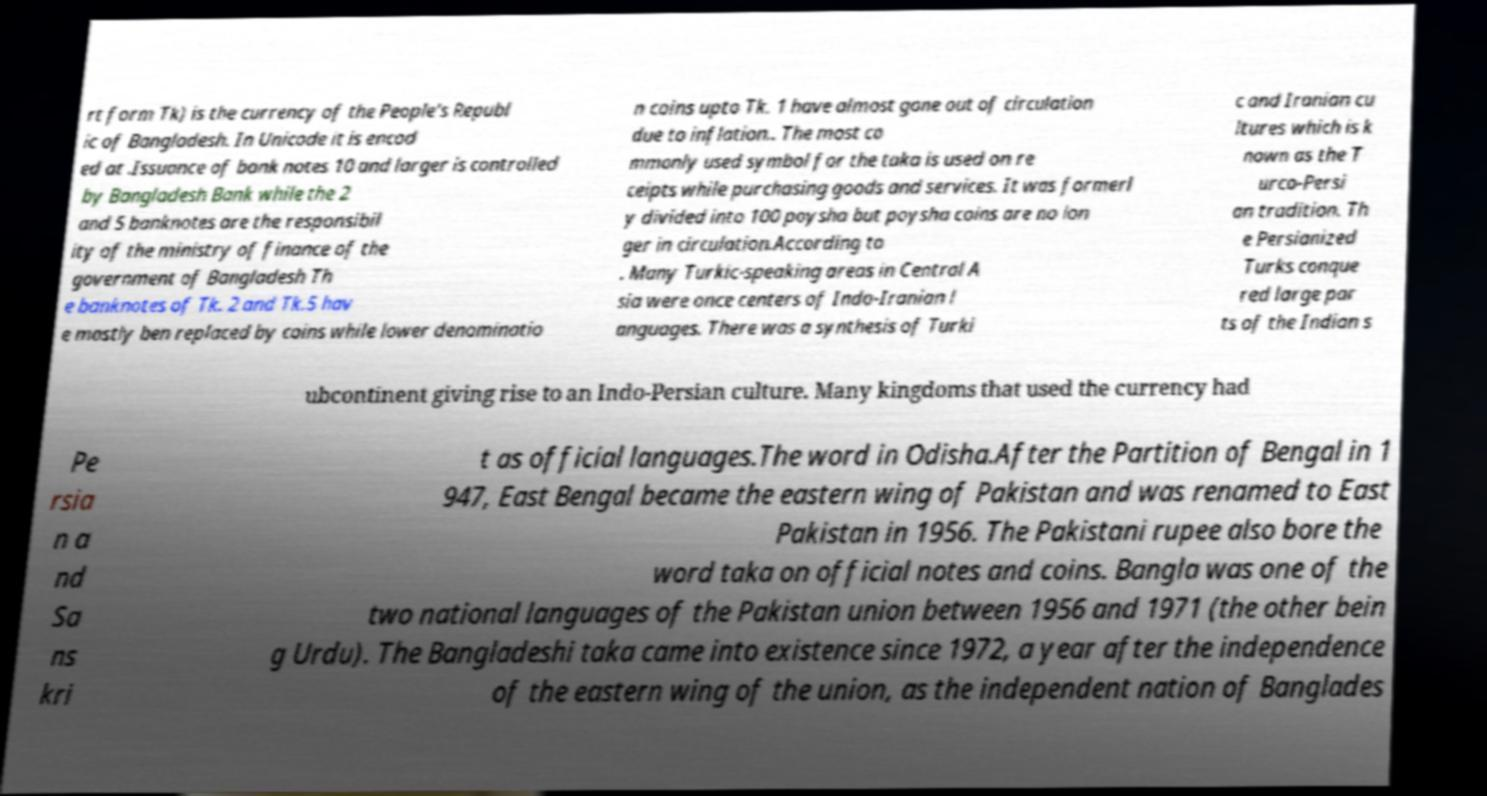I need the written content from this picture converted into text. Can you do that? rt form Tk) is the currency of the People's Republ ic of Bangladesh. In Unicode it is encod ed at .Issuance of bank notes 10 and larger is controlled by Bangladesh Bank while the 2 and 5 banknotes are the responsibil ity of the ministry of finance of the government of Bangladesh Th e banknotes of Tk. 2 and Tk.5 hav e mostly ben replaced by coins while lower denominatio n coins upto Tk. 1 have almost gone out of circulation due to inflation.. The most co mmonly used symbol for the taka is used on re ceipts while purchasing goods and services. It was formerl y divided into 100 poysha but poysha coins are no lon ger in circulation.According to . Many Turkic-speaking areas in Central A sia were once centers of Indo-Iranian l anguages. There was a synthesis of Turki c and Iranian cu ltures which is k nown as the T urco-Persi an tradition. Th e Persianized Turks conque red large par ts of the Indian s ubcontinent giving rise to an Indo-Persian culture. Many kingdoms that used the currency had Pe rsia n a nd Sa ns kri t as official languages.The word in Odisha.After the Partition of Bengal in 1 947, East Bengal became the eastern wing of Pakistan and was renamed to East Pakistan in 1956. The Pakistani rupee also bore the word taka on official notes and coins. Bangla was one of the two national languages of the Pakistan union between 1956 and 1971 (the other bein g Urdu). The Bangladeshi taka came into existence since 1972, a year after the independence of the eastern wing of the union, as the independent nation of Banglades 